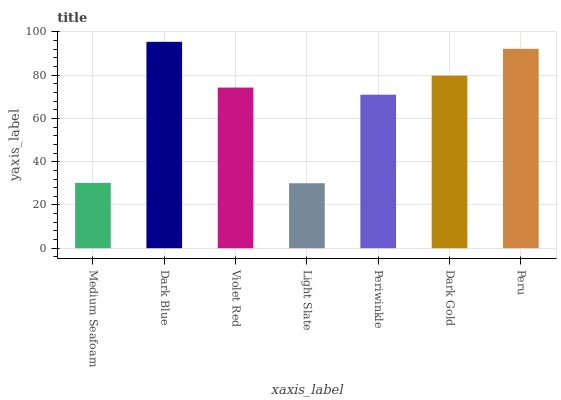Is Light Slate the minimum?
Answer yes or no. Yes. Is Dark Blue the maximum?
Answer yes or no. Yes. Is Violet Red the minimum?
Answer yes or no. No. Is Violet Red the maximum?
Answer yes or no. No. Is Dark Blue greater than Violet Red?
Answer yes or no. Yes. Is Violet Red less than Dark Blue?
Answer yes or no. Yes. Is Violet Red greater than Dark Blue?
Answer yes or no. No. Is Dark Blue less than Violet Red?
Answer yes or no. No. Is Violet Red the high median?
Answer yes or no. Yes. Is Violet Red the low median?
Answer yes or no. Yes. Is Light Slate the high median?
Answer yes or no. No. Is Dark Gold the low median?
Answer yes or no. No. 